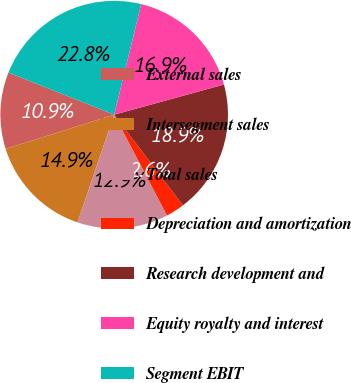<chart> <loc_0><loc_0><loc_500><loc_500><pie_chart><fcel>External sales<fcel>Intersegment sales<fcel>Total sales<fcel>Depreciation and amortization<fcel>Research development and<fcel>Equity royalty and interest<fcel>Segment EBIT<nl><fcel>10.89%<fcel>14.92%<fcel>12.9%<fcel>2.64%<fcel>18.94%<fcel>16.93%<fcel>22.77%<nl></chart> 